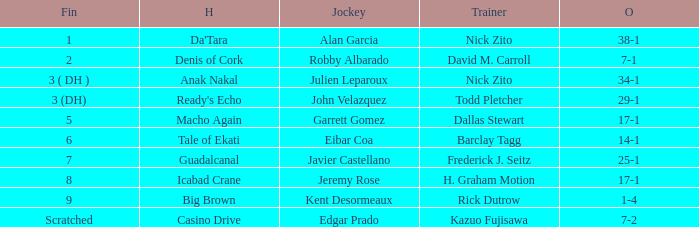What is the Finished place for da'tara trained by Nick zito? 1.0. 